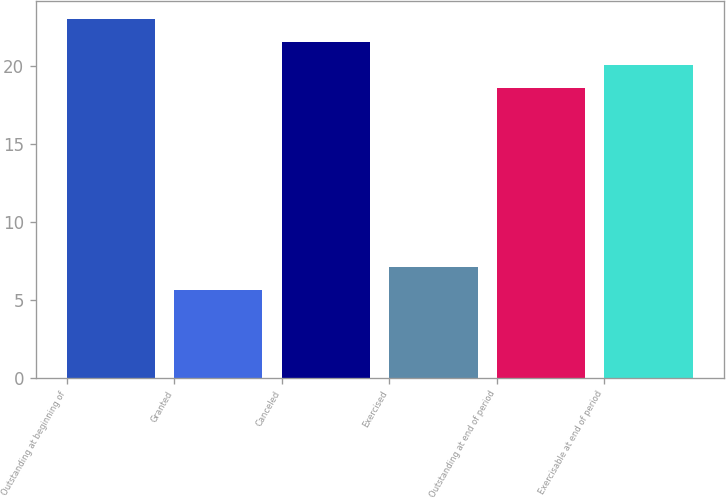Convert chart to OTSL. <chart><loc_0><loc_0><loc_500><loc_500><bar_chart><fcel>Outstanding at beginning of<fcel>Granted<fcel>Canceled<fcel>Exercised<fcel>Outstanding at end of period<fcel>Exercisable at end of period<nl><fcel>23.02<fcel>5.62<fcel>21.54<fcel>7.1<fcel>18.58<fcel>20.06<nl></chart> 